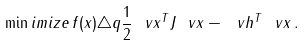<formula> <loc_0><loc_0><loc_500><loc_500>\min i m i z e \, f ( x ) \triangle q \frac { 1 } { 2 } \ v x ^ { T } J \ v x - \ v h ^ { T } \ v x \, .</formula> 